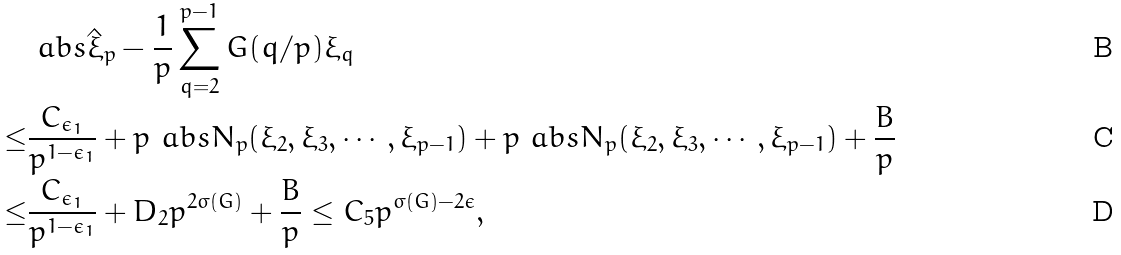<formula> <loc_0><loc_0><loc_500><loc_500>& \ a b s { \hat { \xi } _ { p } - \frac { 1 } { p } \sum _ { q = 2 } ^ { p - 1 } G ( q / p ) \xi _ { q } } \\ \leq & \frac { C _ { \epsilon _ { 1 } } } { p ^ { 1 - \epsilon _ { 1 } } } + p \ a b s { N _ { p } ( \xi _ { 2 } , \xi _ { 3 } , \cdots , \xi _ { p - 1 } ) } + p \ a b s { N _ { p } ( \xi _ { 2 } , \xi _ { 3 } , \cdots , \xi _ { p - 1 } ) } + \frac { B } { p } \\ \leq & \frac { C _ { \epsilon _ { 1 } } } { p ^ { 1 - \epsilon _ { 1 } } } + { D _ { 2 } } { p ^ { 2 \sigma ( G ) } } + \frac { B } { p } \leq C _ { 5 } p ^ { \sigma ( G ) - 2 \epsilon } ,</formula> 